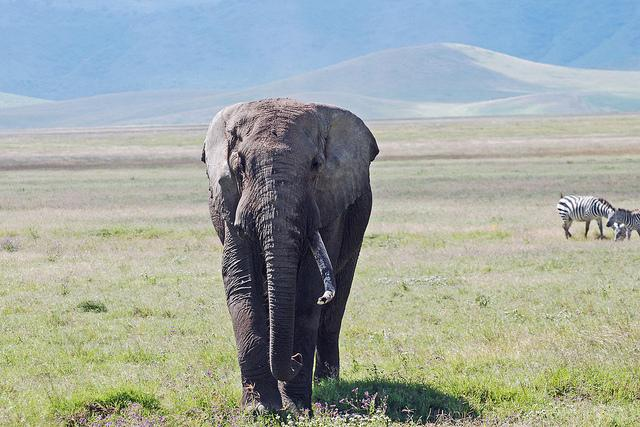What is the elephant missing on its right side? Please explain your reasoning. tusk. Elephants normally have two tusks and not one. 